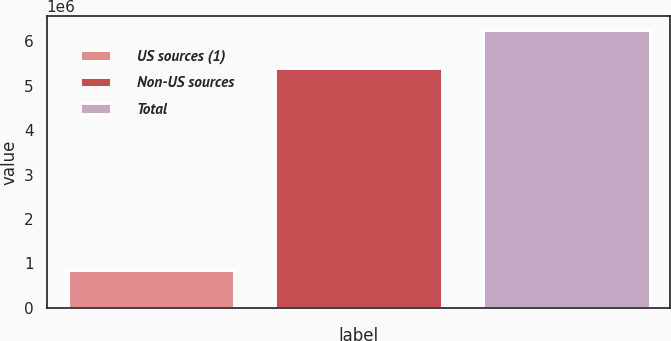Convert chart to OTSL. <chart><loc_0><loc_0><loc_500><loc_500><bar_chart><fcel>US sources (1)<fcel>Non-US sources<fcel>Total<nl><fcel>853173<fcel>5.39862e+06<fcel>6.2518e+06<nl></chart> 